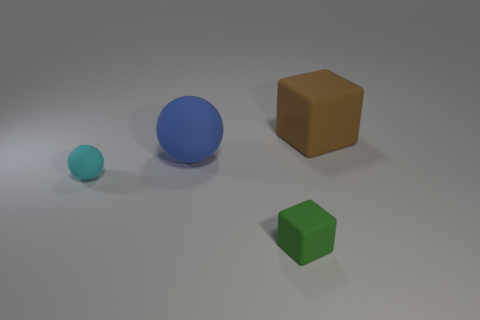How many blocks are both behind the cyan matte sphere and in front of the big brown rubber cube?
Provide a short and direct response. 0. What size is the other sphere that is the same material as the blue ball?
Give a very brief answer. Small. The cyan matte object has what size?
Keep it short and to the point. Small. What material is the cyan ball?
Offer a terse response. Rubber. Is the size of the matte cube that is in front of the cyan object the same as the blue rubber ball?
Make the answer very short. No. How many objects are gray blocks or matte blocks?
Give a very brief answer. 2. There is a rubber thing that is behind the tiny cyan object and to the left of the brown rubber block; what size is it?
Offer a terse response. Large. How many tiny cyan blocks are there?
Provide a short and direct response. 0. How many blocks are big rubber things or small green matte things?
Provide a short and direct response. 2. There is a block behind the big rubber thing that is on the left side of the brown object; how many blue balls are in front of it?
Offer a very short reply. 1. 